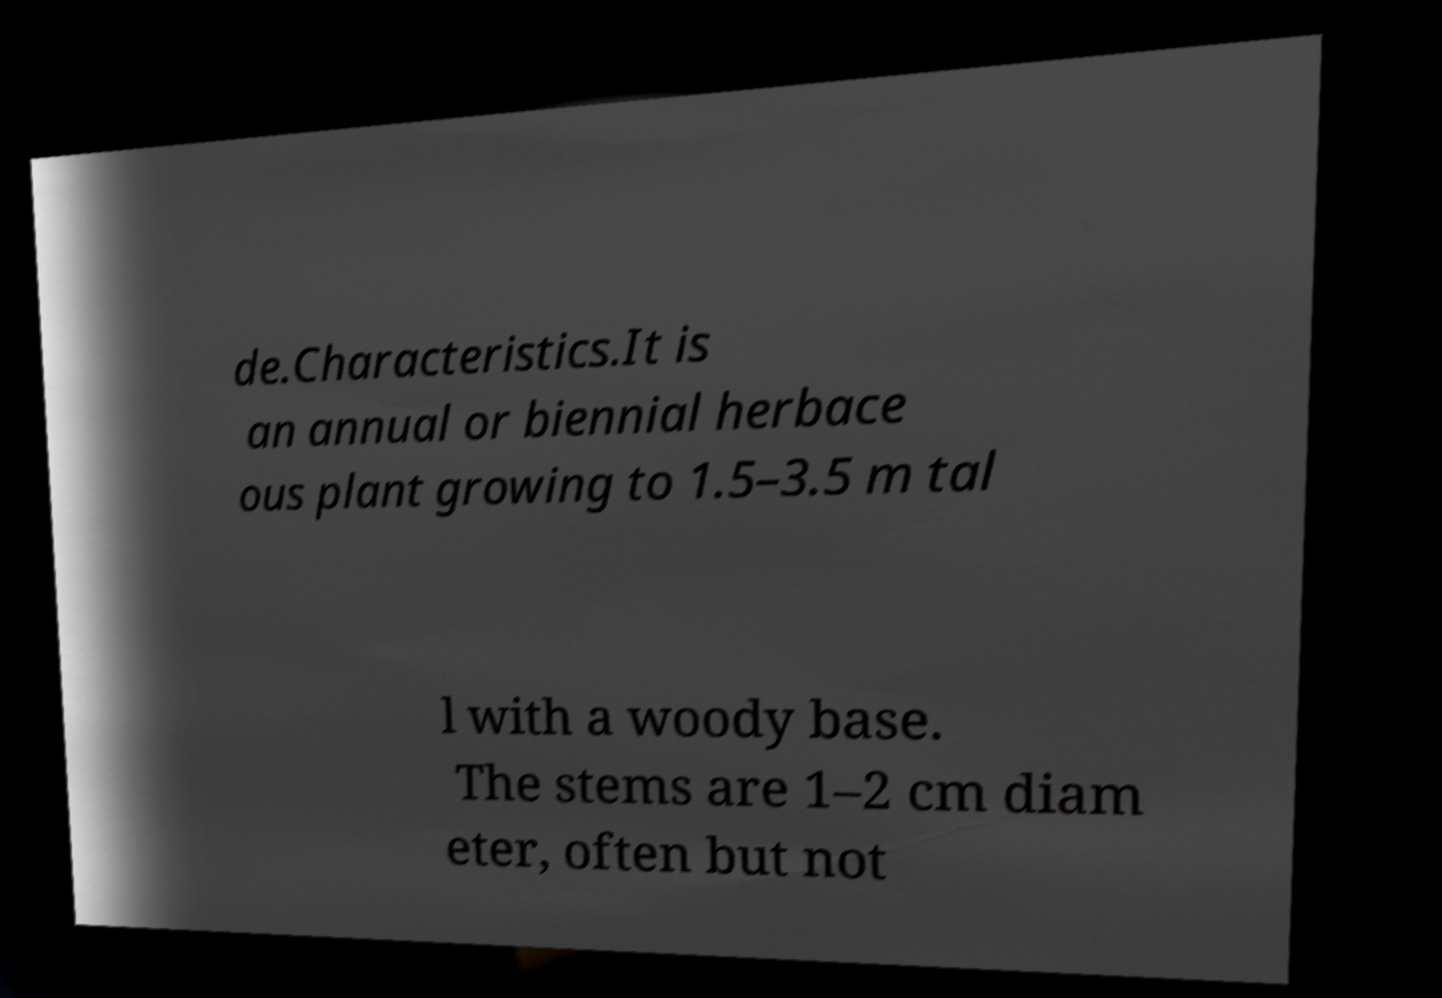I need the written content from this picture converted into text. Can you do that? de.Characteristics.It is an annual or biennial herbace ous plant growing to 1.5–3.5 m tal l with a woody base. The stems are 1–2 cm diam eter, often but not 